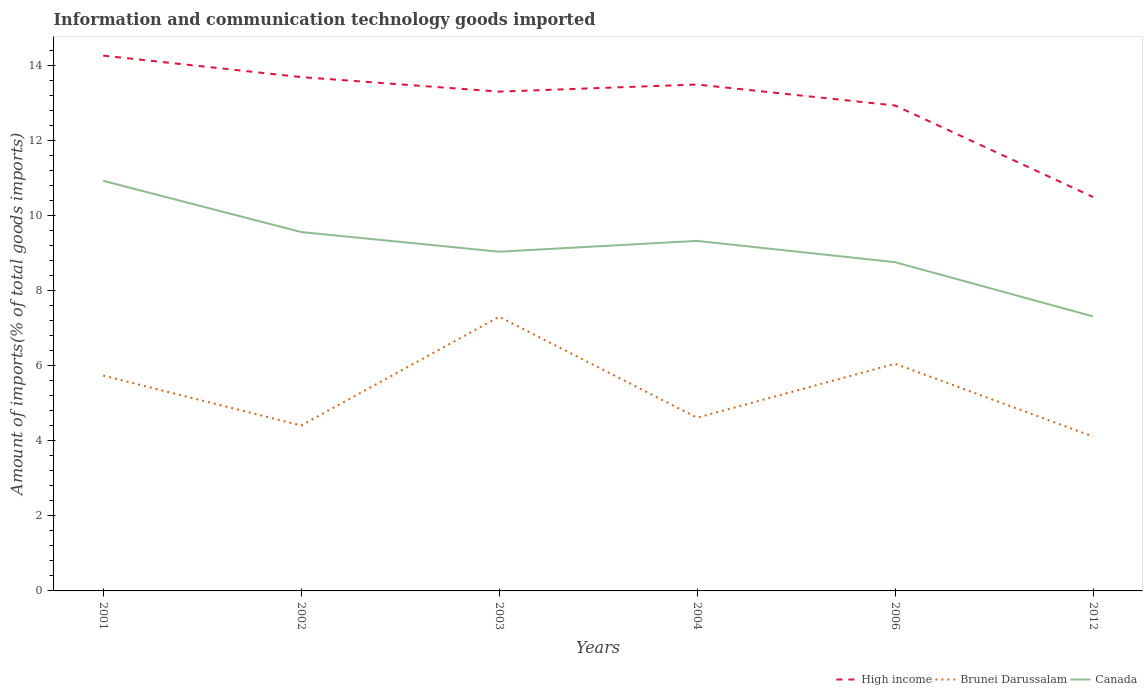Across all years, what is the maximum amount of goods imported in High income?
Keep it short and to the point. 10.5. What is the total amount of goods imported in High income in the graph?
Your response must be concise. 1.33. What is the difference between the highest and the second highest amount of goods imported in Brunei Darussalam?
Provide a succinct answer. 3.19. What is the difference between the highest and the lowest amount of goods imported in High income?
Provide a succinct answer. 4. Is the amount of goods imported in Brunei Darussalam strictly greater than the amount of goods imported in High income over the years?
Offer a very short reply. Yes. Are the values on the major ticks of Y-axis written in scientific E-notation?
Ensure brevity in your answer.  No. Does the graph contain any zero values?
Offer a very short reply. No. Where does the legend appear in the graph?
Provide a succinct answer. Bottom right. How many legend labels are there?
Make the answer very short. 3. How are the legend labels stacked?
Your answer should be very brief. Horizontal. What is the title of the graph?
Ensure brevity in your answer.  Information and communication technology goods imported. Does "Tanzania" appear as one of the legend labels in the graph?
Provide a short and direct response. No. What is the label or title of the X-axis?
Your answer should be compact. Years. What is the label or title of the Y-axis?
Provide a succinct answer. Amount of imports(% of total goods imports). What is the Amount of imports(% of total goods imports) in High income in 2001?
Make the answer very short. 14.27. What is the Amount of imports(% of total goods imports) in Brunei Darussalam in 2001?
Ensure brevity in your answer.  5.74. What is the Amount of imports(% of total goods imports) of Canada in 2001?
Offer a very short reply. 10.93. What is the Amount of imports(% of total goods imports) of High income in 2002?
Keep it short and to the point. 13.7. What is the Amount of imports(% of total goods imports) of Brunei Darussalam in 2002?
Give a very brief answer. 4.41. What is the Amount of imports(% of total goods imports) of Canada in 2002?
Provide a short and direct response. 9.57. What is the Amount of imports(% of total goods imports) in High income in 2003?
Offer a very short reply. 13.31. What is the Amount of imports(% of total goods imports) of Brunei Darussalam in 2003?
Ensure brevity in your answer.  7.31. What is the Amount of imports(% of total goods imports) in Canada in 2003?
Offer a terse response. 9.04. What is the Amount of imports(% of total goods imports) in High income in 2004?
Offer a terse response. 13.5. What is the Amount of imports(% of total goods imports) in Brunei Darussalam in 2004?
Make the answer very short. 4.62. What is the Amount of imports(% of total goods imports) of Canada in 2004?
Your answer should be very brief. 9.33. What is the Amount of imports(% of total goods imports) in High income in 2006?
Provide a succinct answer. 12.94. What is the Amount of imports(% of total goods imports) in Brunei Darussalam in 2006?
Your answer should be very brief. 6.06. What is the Amount of imports(% of total goods imports) in Canada in 2006?
Ensure brevity in your answer.  8.76. What is the Amount of imports(% of total goods imports) of High income in 2012?
Provide a short and direct response. 10.5. What is the Amount of imports(% of total goods imports) in Brunei Darussalam in 2012?
Provide a short and direct response. 4.12. What is the Amount of imports(% of total goods imports) in Canada in 2012?
Ensure brevity in your answer.  7.32. Across all years, what is the maximum Amount of imports(% of total goods imports) in High income?
Your response must be concise. 14.27. Across all years, what is the maximum Amount of imports(% of total goods imports) in Brunei Darussalam?
Offer a terse response. 7.31. Across all years, what is the maximum Amount of imports(% of total goods imports) of Canada?
Offer a terse response. 10.93. Across all years, what is the minimum Amount of imports(% of total goods imports) in High income?
Offer a very short reply. 10.5. Across all years, what is the minimum Amount of imports(% of total goods imports) of Brunei Darussalam?
Keep it short and to the point. 4.12. Across all years, what is the minimum Amount of imports(% of total goods imports) in Canada?
Ensure brevity in your answer.  7.32. What is the total Amount of imports(% of total goods imports) in High income in the graph?
Your response must be concise. 78.22. What is the total Amount of imports(% of total goods imports) of Brunei Darussalam in the graph?
Keep it short and to the point. 32.25. What is the total Amount of imports(% of total goods imports) of Canada in the graph?
Provide a succinct answer. 54.95. What is the difference between the Amount of imports(% of total goods imports) of High income in 2001 and that in 2002?
Ensure brevity in your answer.  0.57. What is the difference between the Amount of imports(% of total goods imports) in Brunei Darussalam in 2001 and that in 2002?
Keep it short and to the point. 1.33. What is the difference between the Amount of imports(% of total goods imports) in Canada in 2001 and that in 2002?
Provide a short and direct response. 1.37. What is the difference between the Amount of imports(% of total goods imports) in High income in 2001 and that in 2003?
Keep it short and to the point. 0.96. What is the difference between the Amount of imports(% of total goods imports) of Brunei Darussalam in 2001 and that in 2003?
Provide a succinct answer. -1.57. What is the difference between the Amount of imports(% of total goods imports) in Canada in 2001 and that in 2003?
Provide a succinct answer. 1.89. What is the difference between the Amount of imports(% of total goods imports) in High income in 2001 and that in 2004?
Your answer should be very brief. 0.77. What is the difference between the Amount of imports(% of total goods imports) in Brunei Darussalam in 2001 and that in 2004?
Provide a short and direct response. 1.12. What is the difference between the Amount of imports(% of total goods imports) in Canada in 2001 and that in 2004?
Keep it short and to the point. 1.6. What is the difference between the Amount of imports(% of total goods imports) of High income in 2001 and that in 2006?
Your answer should be compact. 1.33. What is the difference between the Amount of imports(% of total goods imports) in Brunei Darussalam in 2001 and that in 2006?
Offer a terse response. -0.32. What is the difference between the Amount of imports(% of total goods imports) in Canada in 2001 and that in 2006?
Give a very brief answer. 2.17. What is the difference between the Amount of imports(% of total goods imports) of High income in 2001 and that in 2012?
Your response must be concise. 3.77. What is the difference between the Amount of imports(% of total goods imports) of Brunei Darussalam in 2001 and that in 2012?
Your answer should be very brief. 1.62. What is the difference between the Amount of imports(% of total goods imports) of Canada in 2001 and that in 2012?
Provide a short and direct response. 3.61. What is the difference between the Amount of imports(% of total goods imports) in High income in 2002 and that in 2003?
Provide a succinct answer. 0.39. What is the difference between the Amount of imports(% of total goods imports) in Brunei Darussalam in 2002 and that in 2003?
Your answer should be very brief. -2.9. What is the difference between the Amount of imports(% of total goods imports) of Canada in 2002 and that in 2003?
Ensure brevity in your answer.  0.52. What is the difference between the Amount of imports(% of total goods imports) of High income in 2002 and that in 2004?
Provide a short and direct response. 0.2. What is the difference between the Amount of imports(% of total goods imports) in Brunei Darussalam in 2002 and that in 2004?
Offer a very short reply. -0.21. What is the difference between the Amount of imports(% of total goods imports) in Canada in 2002 and that in 2004?
Your response must be concise. 0.24. What is the difference between the Amount of imports(% of total goods imports) in High income in 2002 and that in 2006?
Offer a terse response. 0.76. What is the difference between the Amount of imports(% of total goods imports) in Brunei Darussalam in 2002 and that in 2006?
Keep it short and to the point. -1.65. What is the difference between the Amount of imports(% of total goods imports) of Canada in 2002 and that in 2006?
Keep it short and to the point. 0.8. What is the difference between the Amount of imports(% of total goods imports) of High income in 2002 and that in 2012?
Offer a very short reply. 3.2. What is the difference between the Amount of imports(% of total goods imports) of Brunei Darussalam in 2002 and that in 2012?
Provide a succinct answer. 0.29. What is the difference between the Amount of imports(% of total goods imports) in Canada in 2002 and that in 2012?
Keep it short and to the point. 2.25. What is the difference between the Amount of imports(% of total goods imports) of High income in 2003 and that in 2004?
Ensure brevity in your answer.  -0.19. What is the difference between the Amount of imports(% of total goods imports) of Brunei Darussalam in 2003 and that in 2004?
Make the answer very short. 2.69. What is the difference between the Amount of imports(% of total goods imports) of Canada in 2003 and that in 2004?
Provide a short and direct response. -0.29. What is the difference between the Amount of imports(% of total goods imports) in High income in 2003 and that in 2006?
Offer a very short reply. 0.37. What is the difference between the Amount of imports(% of total goods imports) of Brunei Darussalam in 2003 and that in 2006?
Offer a terse response. 1.25. What is the difference between the Amount of imports(% of total goods imports) in Canada in 2003 and that in 2006?
Give a very brief answer. 0.28. What is the difference between the Amount of imports(% of total goods imports) in High income in 2003 and that in 2012?
Offer a very short reply. 2.81. What is the difference between the Amount of imports(% of total goods imports) in Brunei Darussalam in 2003 and that in 2012?
Give a very brief answer. 3.19. What is the difference between the Amount of imports(% of total goods imports) of Canada in 2003 and that in 2012?
Provide a short and direct response. 1.73. What is the difference between the Amount of imports(% of total goods imports) in High income in 2004 and that in 2006?
Provide a short and direct response. 0.56. What is the difference between the Amount of imports(% of total goods imports) of Brunei Darussalam in 2004 and that in 2006?
Your answer should be compact. -1.44. What is the difference between the Amount of imports(% of total goods imports) in Canada in 2004 and that in 2006?
Keep it short and to the point. 0.57. What is the difference between the Amount of imports(% of total goods imports) of High income in 2004 and that in 2012?
Your answer should be compact. 3. What is the difference between the Amount of imports(% of total goods imports) in Brunei Darussalam in 2004 and that in 2012?
Provide a short and direct response. 0.5. What is the difference between the Amount of imports(% of total goods imports) in Canada in 2004 and that in 2012?
Give a very brief answer. 2.01. What is the difference between the Amount of imports(% of total goods imports) in High income in 2006 and that in 2012?
Provide a succinct answer. 2.44. What is the difference between the Amount of imports(% of total goods imports) in Brunei Darussalam in 2006 and that in 2012?
Provide a short and direct response. 1.94. What is the difference between the Amount of imports(% of total goods imports) of Canada in 2006 and that in 2012?
Provide a succinct answer. 1.45. What is the difference between the Amount of imports(% of total goods imports) in High income in 2001 and the Amount of imports(% of total goods imports) in Brunei Darussalam in 2002?
Give a very brief answer. 9.86. What is the difference between the Amount of imports(% of total goods imports) in High income in 2001 and the Amount of imports(% of total goods imports) in Canada in 2002?
Give a very brief answer. 4.7. What is the difference between the Amount of imports(% of total goods imports) of Brunei Darussalam in 2001 and the Amount of imports(% of total goods imports) of Canada in 2002?
Provide a short and direct response. -3.83. What is the difference between the Amount of imports(% of total goods imports) of High income in 2001 and the Amount of imports(% of total goods imports) of Brunei Darussalam in 2003?
Give a very brief answer. 6.96. What is the difference between the Amount of imports(% of total goods imports) of High income in 2001 and the Amount of imports(% of total goods imports) of Canada in 2003?
Ensure brevity in your answer.  5.23. What is the difference between the Amount of imports(% of total goods imports) in Brunei Darussalam in 2001 and the Amount of imports(% of total goods imports) in Canada in 2003?
Your answer should be very brief. -3.3. What is the difference between the Amount of imports(% of total goods imports) in High income in 2001 and the Amount of imports(% of total goods imports) in Brunei Darussalam in 2004?
Offer a very short reply. 9.65. What is the difference between the Amount of imports(% of total goods imports) in High income in 2001 and the Amount of imports(% of total goods imports) in Canada in 2004?
Ensure brevity in your answer.  4.94. What is the difference between the Amount of imports(% of total goods imports) of Brunei Darussalam in 2001 and the Amount of imports(% of total goods imports) of Canada in 2004?
Your response must be concise. -3.59. What is the difference between the Amount of imports(% of total goods imports) in High income in 2001 and the Amount of imports(% of total goods imports) in Brunei Darussalam in 2006?
Your response must be concise. 8.21. What is the difference between the Amount of imports(% of total goods imports) of High income in 2001 and the Amount of imports(% of total goods imports) of Canada in 2006?
Your answer should be compact. 5.51. What is the difference between the Amount of imports(% of total goods imports) in Brunei Darussalam in 2001 and the Amount of imports(% of total goods imports) in Canada in 2006?
Give a very brief answer. -3.02. What is the difference between the Amount of imports(% of total goods imports) of High income in 2001 and the Amount of imports(% of total goods imports) of Brunei Darussalam in 2012?
Provide a short and direct response. 10.15. What is the difference between the Amount of imports(% of total goods imports) in High income in 2001 and the Amount of imports(% of total goods imports) in Canada in 2012?
Give a very brief answer. 6.95. What is the difference between the Amount of imports(% of total goods imports) in Brunei Darussalam in 2001 and the Amount of imports(% of total goods imports) in Canada in 2012?
Give a very brief answer. -1.58. What is the difference between the Amount of imports(% of total goods imports) in High income in 2002 and the Amount of imports(% of total goods imports) in Brunei Darussalam in 2003?
Ensure brevity in your answer.  6.39. What is the difference between the Amount of imports(% of total goods imports) of High income in 2002 and the Amount of imports(% of total goods imports) of Canada in 2003?
Provide a succinct answer. 4.65. What is the difference between the Amount of imports(% of total goods imports) in Brunei Darussalam in 2002 and the Amount of imports(% of total goods imports) in Canada in 2003?
Provide a short and direct response. -4.63. What is the difference between the Amount of imports(% of total goods imports) in High income in 2002 and the Amount of imports(% of total goods imports) in Brunei Darussalam in 2004?
Your answer should be very brief. 9.08. What is the difference between the Amount of imports(% of total goods imports) of High income in 2002 and the Amount of imports(% of total goods imports) of Canada in 2004?
Your response must be concise. 4.37. What is the difference between the Amount of imports(% of total goods imports) of Brunei Darussalam in 2002 and the Amount of imports(% of total goods imports) of Canada in 2004?
Your answer should be compact. -4.92. What is the difference between the Amount of imports(% of total goods imports) of High income in 2002 and the Amount of imports(% of total goods imports) of Brunei Darussalam in 2006?
Keep it short and to the point. 7.64. What is the difference between the Amount of imports(% of total goods imports) in High income in 2002 and the Amount of imports(% of total goods imports) in Canada in 2006?
Provide a succinct answer. 4.93. What is the difference between the Amount of imports(% of total goods imports) in Brunei Darussalam in 2002 and the Amount of imports(% of total goods imports) in Canada in 2006?
Your answer should be very brief. -4.35. What is the difference between the Amount of imports(% of total goods imports) of High income in 2002 and the Amount of imports(% of total goods imports) of Brunei Darussalam in 2012?
Your answer should be very brief. 9.58. What is the difference between the Amount of imports(% of total goods imports) in High income in 2002 and the Amount of imports(% of total goods imports) in Canada in 2012?
Your answer should be very brief. 6.38. What is the difference between the Amount of imports(% of total goods imports) in Brunei Darussalam in 2002 and the Amount of imports(% of total goods imports) in Canada in 2012?
Keep it short and to the point. -2.91. What is the difference between the Amount of imports(% of total goods imports) in High income in 2003 and the Amount of imports(% of total goods imports) in Brunei Darussalam in 2004?
Make the answer very short. 8.69. What is the difference between the Amount of imports(% of total goods imports) in High income in 2003 and the Amount of imports(% of total goods imports) in Canada in 2004?
Your answer should be compact. 3.98. What is the difference between the Amount of imports(% of total goods imports) of Brunei Darussalam in 2003 and the Amount of imports(% of total goods imports) of Canada in 2004?
Provide a short and direct response. -2.02. What is the difference between the Amount of imports(% of total goods imports) of High income in 2003 and the Amount of imports(% of total goods imports) of Brunei Darussalam in 2006?
Your answer should be compact. 7.25. What is the difference between the Amount of imports(% of total goods imports) of High income in 2003 and the Amount of imports(% of total goods imports) of Canada in 2006?
Ensure brevity in your answer.  4.55. What is the difference between the Amount of imports(% of total goods imports) in Brunei Darussalam in 2003 and the Amount of imports(% of total goods imports) in Canada in 2006?
Provide a short and direct response. -1.45. What is the difference between the Amount of imports(% of total goods imports) of High income in 2003 and the Amount of imports(% of total goods imports) of Brunei Darussalam in 2012?
Your answer should be very brief. 9.19. What is the difference between the Amount of imports(% of total goods imports) of High income in 2003 and the Amount of imports(% of total goods imports) of Canada in 2012?
Your response must be concise. 5.99. What is the difference between the Amount of imports(% of total goods imports) of Brunei Darussalam in 2003 and the Amount of imports(% of total goods imports) of Canada in 2012?
Ensure brevity in your answer.  -0.01. What is the difference between the Amount of imports(% of total goods imports) of High income in 2004 and the Amount of imports(% of total goods imports) of Brunei Darussalam in 2006?
Give a very brief answer. 7.44. What is the difference between the Amount of imports(% of total goods imports) of High income in 2004 and the Amount of imports(% of total goods imports) of Canada in 2006?
Ensure brevity in your answer.  4.74. What is the difference between the Amount of imports(% of total goods imports) of Brunei Darussalam in 2004 and the Amount of imports(% of total goods imports) of Canada in 2006?
Offer a terse response. -4.15. What is the difference between the Amount of imports(% of total goods imports) in High income in 2004 and the Amount of imports(% of total goods imports) in Brunei Darussalam in 2012?
Give a very brief answer. 9.38. What is the difference between the Amount of imports(% of total goods imports) in High income in 2004 and the Amount of imports(% of total goods imports) in Canada in 2012?
Give a very brief answer. 6.18. What is the difference between the Amount of imports(% of total goods imports) of Brunei Darussalam in 2004 and the Amount of imports(% of total goods imports) of Canada in 2012?
Your answer should be very brief. -2.7. What is the difference between the Amount of imports(% of total goods imports) of High income in 2006 and the Amount of imports(% of total goods imports) of Brunei Darussalam in 2012?
Make the answer very short. 8.82. What is the difference between the Amount of imports(% of total goods imports) in High income in 2006 and the Amount of imports(% of total goods imports) in Canada in 2012?
Make the answer very short. 5.62. What is the difference between the Amount of imports(% of total goods imports) in Brunei Darussalam in 2006 and the Amount of imports(% of total goods imports) in Canada in 2012?
Offer a very short reply. -1.26. What is the average Amount of imports(% of total goods imports) in High income per year?
Give a very brief answer. 13.04. What is the average Amount of imports(% of total goods imports) of Brunei Darussalam per year?
Provide a succinct answer. 5.37. What is the average Amount of imports(% of total goods imports) in Canada per year?
Offer a very short reply. 9.16. In the year 2001, what is the difference between the Amount of imports(% of total goods imports) in High income and Amount of imports(% of total goods imports) in Brunei Darussalam?
Give a very brief answer. 8.53. In the year 2001, what is the difference between the Amount of imports(% of total goods imports) in High income and Amount of imports(% of total goods imports) in Canada?
Give a very brief answer. 3.34. In the year 2001, what is the difference between the Amount of imports(% of total goods imports) in Brunei Darussalam and Amount of imports(% of total goods imports) in Canada?
Your answer should be very brief. -5.19. In the year 2002, what is the difference between the Amount of imports(% of total goods imports) in High income and Amount of imports(% of total goods imports) in Brunei Darussalam?
Your answer should be very brief. 9.29. In the year 2002, what is the difference between the Amount of imports(% of total goods imports) in High income and Amount of imports(% of total goods imports) in Canada?
Offer a terse response. 4.13. In the year 2002, what is the difference between the Amount of imports(% of total goods imports) in Brunei Darussalam and Amount of imports(% of total goods imports) in Canada?
Offer a very short reply. -5.16. In the year 2003, what is the difference between the Amount of imports(% of total goods imports) of High income and Amount of imports(% of total goods imports) of Brunei Darussalam?
Your response must be concise. 6. In the year 2003, what is the difference between the Amount of imports(% of total goods imports) in High income and Amount of imports(% of total goods imports) in Canada?
Provide a succinct answer. 4.27. In the year 2003, what is the difference between the Amount of imports(% of total goods imports) in Brunei Darussalam and Amount of imports(% of total goods imports) in Canada?
Your answer should be compact. -1.73. In the year 2004, what is the difference between the Amount of imports(% of total goods imports) in High income and Amount of imports(% of total goods imports) in Brunei Darussalam?
Offer a very short reply. 8.88. In the year 2004, what is the difference between the Amount of imports(% of total goods imports) in High income and Amount of imports(% of total goods imports) in Canada?
Ensure brevity in your answer.  4.17. In the year 2004, what is the difference between the Amount of imports(% of total goods imports) in Brunei Darussalam and Amount of imports(% of total goods imports) in Canada?
Offer a very short reply. -4.71. In the year 2006, what is the difference between the Amount of imports(% of total goods imports) in High income and Amount of imports(% of total goods imports) in Brunei Darussalam?
Your answer should be very brief. 6.88. In the year 2006, what is the difference between the Amount of imports(% of total goods imports) of High income and Amount of imports(% of total goods imports) of Canada?
Make the answer very short. 4.18. In the year 2006, what is the difference between the Amount of imports(% of total goods imports) in Brunei Darussalam and Amount of imports(% of total goods imports) in Canada?
Your answer should be compact. -2.71. In the year 2012, what is the difference between the Amount of imports(% of total goods imports) in High income and Amount of imports(% of total goods imports) in Brunei Darussalam?
Keep it short and to the point. 6.38. In the year 2012, what is the difference between the Amount of imports(% of total goods imports) of High income and Amount of imports(% of total goods imports) of Canada?
Your answer should be compact. 3.18. In the year 2012, what is the difference between the Amount of imports(% of total goods imports) of Brunei Darussalam and Amount of imports(% of total goods imports) of Canada?
Your answer should be very brief. -3.2. What is the ratio of the Amount of imports(% of total goods imports) of High income in 2001 to that in 2002?
Your response must be concise. 1.04. What is the ratio of the Amount of imports(% of total goods imports) of Brunei Darussalam in 2001 to that in 2002?
Ensure brevity in your answer.  1.3. What is the ratio of the Amount of imports(% of total goods imports) of Canada in 2001 to that in 2002?
Give a very brief answer. 1.14. What is the ratio of the Amount of imports(% of total goods imports) of High income in 2001 to that in 2003?
Give a very brief answer. 1.07. What is the ratio of the Amount of imports(% of total goods imports) of Brunei Darussalam in 2001 to that in 2003?
Your answer should be very brief. 0.79. What is the ratio of the Amount of imports(% of total goods imports) of Canada in 2001 to that in 2003?
Your response must be concise. 1.21. What is the ratio of the Amount of imports(% of total goods imports) in High income in 2001 to that in 2004?
Make the answer very short. 1.06. What is the ratio of the Amount of imports(% of total goods imports) in Brunei Darussalam in 2001 to that in 2004?
Offer a terse response. 1.24. What is the ratio of the Amount of imports(% of total goods imports) in Canada in 2001 to that in 2004?
Ensure brevity in your answer.  1.17. What is the ratio of the Amount of imports(% of total goods imports) in High income in 2001 to that in 2006?
Offer a terse response. 1.1. What is the ratio of the Amount of imports(% of total goods imports) of Brunei Darussalam in 2001 to that in 2006?
Provide a short and direct response. 0.95. What is the ratio of the Amount of imports(% of total goods imports) in Canada in 2001 to that in 2006?
Make the answer very short. 1.25. What is the ratio of the Amount of imports(% of total goods imports) of High income in 2001 to that in 2012?
Your answer should be compact. 1.36. What is the ratio of the Amount of imports(% of total goods imports) in Brunei Darussalam in 2001 to that in 2012?
Your response must be concise. 1.39. What is the ratio of the Amount of imports(% of total goods imports) in Canada in 2001 to that in 2012?
Keep it short and to the point. 1.49. What is the ratio of the Amount of imports(% of total goods imports) in High income in 2002 to that in 2003?
Offer a terse response. 1.03. What is the ratio of the Amount of imports(% of total goods imports) in Brunei Darussalam in 2002 to that in 2003?
Provide a succinct answer. 0.6. What is the ratio of the Amount of imports(% of total goods imports) of Canada in 2002 to that in 2003?
Your answer should be very brief. 1.06. What is the ratio of the Amount of imports(% of total goods imports) of High income in 2002 to that in 2004?
Ensure brevity in your answer.  1.01. What is the ratio of the Amount of imports(% of total goods imports) of Brunei Darussalam in 2002 to that in 2004?
Your response must be concise. 0.96. What is the ratio of the Amount of imports(% of total goods imports) of Canada in 2002 to that in 2004?
Offer a very short reply. 1.03. What is the ratio of the Amount of imports(% of total goods imports) in High income in 2002 to that in 2006?
Give a very brief answer. 1.06. What is the ratio of the Amount of imports(% of total goods imports) of Brunei Darussalam in 2002 to that in 2006?
Offer a terse response. 0.73. What is the ratio of the Amount of imports(% of total goods imports) in Canada in 2002 to that in 2006?
Make the answer very short. 1.09. What is the ratio of the Amount of imports(% of total goods imports) in High income in 2002 to that in 2012?
Your answer should be very brief. 1.3. What is the ratio of the Amount of imports(% of total goods imports) in Brunei Darussalam in 2002 to that in 2012?
Offer a terse response. 1.07. What is the ratio of the Amount of imports(% of total goods imports) in Canada in 2002 to that in 2012?
Your response must be concise. 1.31. What is the ratio of the Amount of imports(% of total goods imports) of Brunei Darussalam in 2003 to that in 2004?
Ensure brevity in your answer.  1.58. What is the ratio of the Amount of imports(% of total goods imports) of Canada in 2003 to that in 2004?
Your response must be concise. 0.97. What is the ratio of the Amount of imports(% of total goods imports) in High income in 2003 to that in 2006?
Provide a short and direct response. 1.03. What is the ratio of the Amount of imports(% of total goods imports) of Brunei Darussalam in 2003 to that in 2006?
Offer a very short reply. 1.21. What is the ratio of the Amount of imports(% of total goods imports) of Canada in 2003 to that in 2006?
Your answer should be very brief. 1.03. What is the ratio of the Amount of imports(% of total goods imports) of High income in 2003 to that in 2012?
Your answer should be very brief. 1.27. What is the ratio of the Amount of imports(% of total goods imports) in Brunei Darussalam in 2003 to that in 2012?
Provide a short and direct response. 1.78. What is the ratio of the Amount of imports(% of total goods imports) of Canada in 2003 to that in 2012?
Your answer should be compact. 1.24. What is the ratio of the Amount of imports(% of total goods imports) in High income in 2004 to that in 2006?
Your answer should be very brief. 1.04. What is the ratio of the Amount of imports(% of total goods imports) in Brunei Darussalam in 2004 to that in 2006?
Make the answer very short. 0.76. What is the ratio of the Amount of imports(% of total goods imports) in Canada in 2004 to that in 2006?
Offer a terse response. 1.06. What is the ratio of the Amount of imports(% of total goods imports) of High income in 2004 to that in 2012?
Offer a very short reply. 1.29. What is the ratio of the Amount of imports(% of total goods imports) in Brunei Darussalam in 2004 to that in 2012?
Give a very brief answer. 1.12. What is the ratio of the Amount of imports(% of total goods imports) of Canada in 2004 to that in 2012?
Your response must be concise. 1.28. What is the ratio of the Amount of imports(% of total goods imports) in High income in 2006 to that in 2012?
Provide a succinct answer. 1.23. What is the ratio of the Amount of imports(% of total goods imports) of Brunei Darussalam in 2006 to that in 2012?
Your answer should be compact. 1.47. What is the ratio of the Amount of imports(% of total goods imports) of Canada in 2006 to that in 2012?
Ensure brevity in your answer.  1.2. What is the difference between the highest and the second highest Amount of imports(% of total goods imports) in High income?
Offer a terse response. 0.57. What is the difference between the highest and the second highest Amount of imports(% of total goods imports) of Brunei Darussalam?
Your response must be concise. 1.25. What is the difference between the highest and the second highest Amount of imports(% of total goods imports) in Canada?
Your response must be concise. 1.37. What is the difference between the highest and the lowest Amount of imports(% of total goods imports) in High income?
Keep it short and to the point. 3.77. What is the difference between the highest and the lowest Amount of imports(% of total goods imports) in Brunei Darussalam?
Offer a terse response. 3.19. What is the difference between the highest and the lowest Amount of imports(% of total goods imports) of Canada?
Your answer should be very brief. 3.61. 